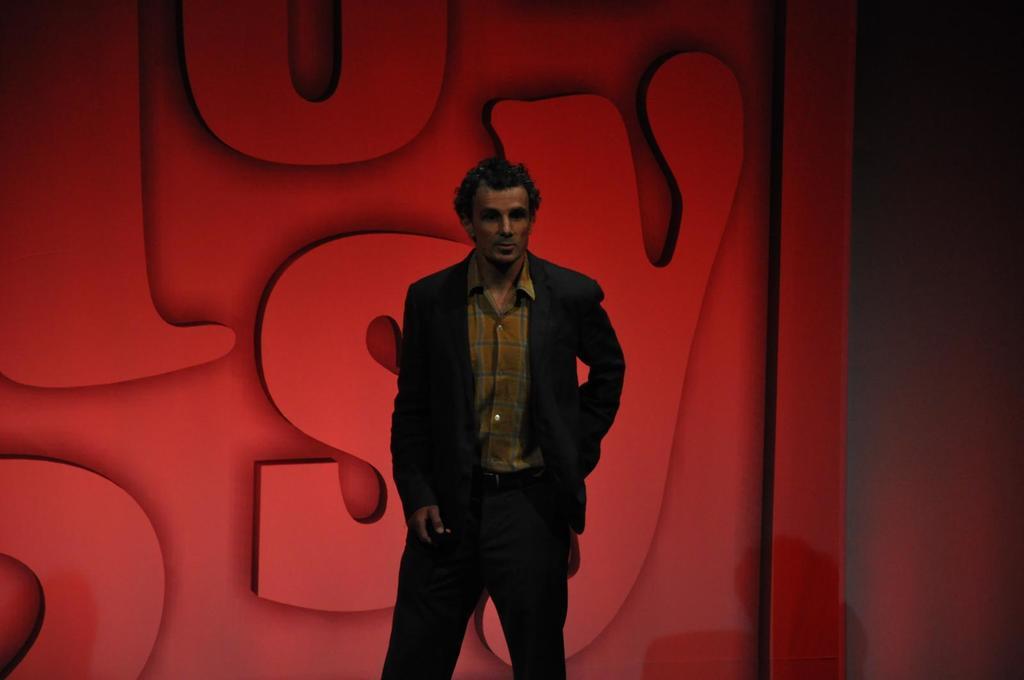Can you describe this image briefly? In this picture, we can see a person, and in the background we can see red color wall with some letters on it. 